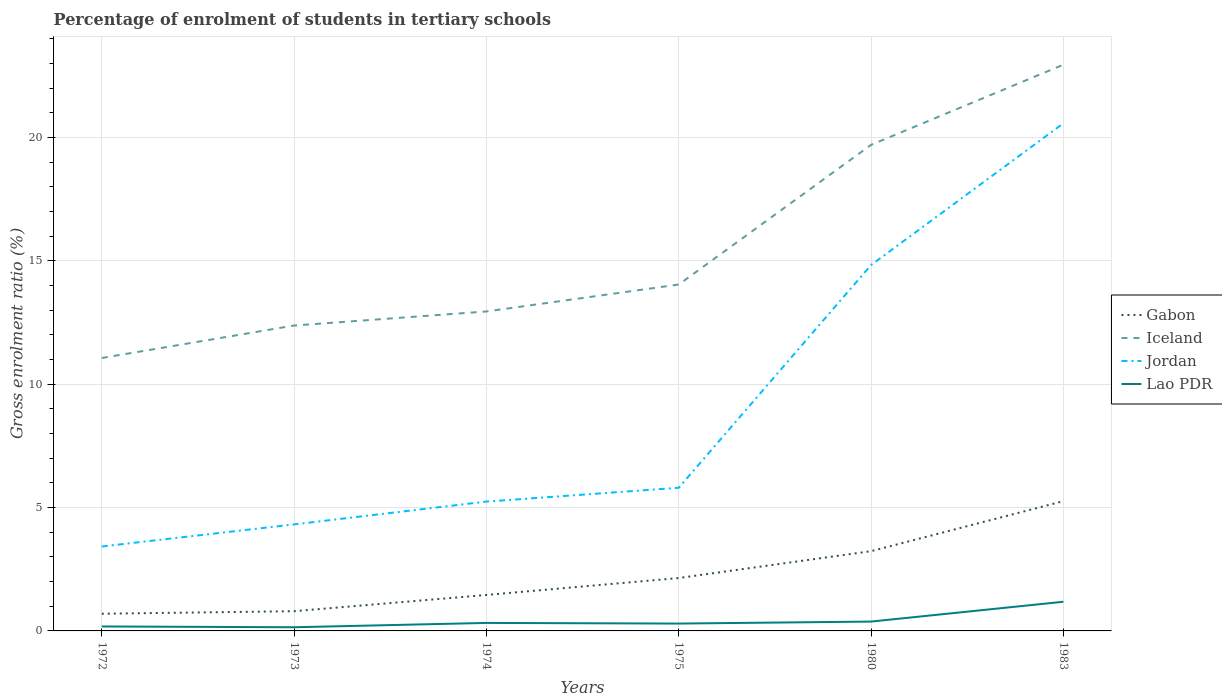Across all years, what is the maximum percentage of students enrolled in tertiary schools in Gabon?
Your response must be concise. 0.7. In which year was the percentage of students enrolled in tertiary schools in Gabon maximum?
Offer a terse response. 1972. What is the total percentage of students enrolled in tertiary schools in Gabon in the graph?
Provide a short and direct response. -3.8. What is the difference between the highest and the second highest percentage of students enrolled in tertiary schools in Jordan?
Provide a short and direct response. 17.16. What is the difference between the highest and the lowest percentage of students enrolled in tertiary schools in Iceland?
Keep it short and to the point. 2. How many lines are there?
Provide a succinct answer. 4. Are the values on the major ticks of Y-axis written in scientific E-notation?
Offer a very short reply. No. Does the graph contain any zero values?
Provide a succinct answer. No. Does the graph contain grids?
Your answer should be compact. Yes. How many legend labels are there?
Your response must be concise. 4. What is the title of the graph?
Give a very brief answer. Percentage of enrolment of students in tertiary schools. What is the label or title of the Y-axis?
Ensure brevity in your answer.  Gross enrolment ratio (%). What is the Gross enrolment ratio (%) of Gabon in 1972?
Keep it short and to the point. 0.7. What is the Gross enrolment ratio (%) of Iceland in 1972?
Your answer should be compact. 11.06. What is the Gross enrolment ratio (%) of Jordan in 1972?
Your answer should be compact. 3.42. What is the Gross enrolment ratio (%) in Lao PDR in 1972?
Offer a very short reply. 0.18. What is the Gross enrolment ratio (%) in Gabon in 1973?
Provide a short and direct response. 0.8. What is the Gross enrolment ratio (%) in Iceland in 1973?
Provide a short and direct response. 12.38. What is the Gross enrolment ratio (%) of Jordan in 1973?
Your answer should be compact. 4.32. What is the Gross enrolment ratio (%) of Lao PDR in 1973?
Your response must be concise. 0.15. What is the Gross enrolment ratio (%) in Gabon in 1974?
Provide a short and direct response. 1.46. What is the Gross enrolment ratio (%) in Iceland in 1974?
Ensure brevity in your answer.  12.95. What is the Gross enrolment ratio (%) in Jordan in 1974?
Give a very brief answer. 5.24. What is the Gross enrolment ratio (%) in Lao PDR in 1974?
Provide a succinct answer. 0.32. What is the Gross enrolment ratio (%) of Gabon in 1975?
Your response must be concise. 2.14. What is the Gross enrolment ratio (%) in Iceland in 1975?
Give a very brief answer. 14.04. What is the Gross enrolment ratio (%) of Jordan in 1975?
Your answer should be compact. 5.8. What is the Gross enrolment ratio (%) of Lao PDR in 1975?
Give a very brief answer. 0.3. What is the Gross enrolment ratio (%) in Gabon in 1980?
Your answer should be compact. 3.23. What is the Gross enrolment ratio (%) of Iceland in 1980?
Keep it short and to the point. 19.71. What is the Gross enrolment ratio (%) of Jordan in 1980?
Offer a terse response. 14.83. What is the Gross enrolment ratio (%) in Lao PDR in 1980?
Provide a succinct answer. 0.38. What is the Gross enrolment ratio (%) in Gabon in 1983?
Offer a very short reply. 5.26. What is the Gross enrolment ratio (%) in Iceland in 1983?
Keep it short and to the point. 22.96. What is the Gross enrolment ratio (%) of Jordan in 1983?
Provide a succinct answer. 20.58. What is the Gross enrolment ratio (%) in Lao PDR in 1983?
Offer a very short reply. 1.18. Across all years, what is the maximum Gross enrolment ratio (%) of Gabon?
Your answer should be very brief. 5.26. Across all years, what is the maximum Gross enrolment ratio (%) of Iceland?
Make the answer very short. 22.96. Across all years, what is the maximum Gross enrolment ratio (%) of Jordan?
Keep it short and to the point. 20.58. Across all years, what is the maximum Gross enrolment ratio (%) in Lao PDR?
Provide a short and direct response. 1.18. Across all years, what is the minimum Gross enrolment ratio (%) in Gabon?
Your response must be concise. 0.7. Across all years, what is the minimum Gross enrolment ratio (%) of Iceland?
Your answer should be very brief. 11.06. Across all years, what is the minimum Gross enrolment ratio (%) in Jordan?
Keep it short and to the point. 3.42. Across all years, what is the minimum Gross enrolment ratio (%) of Lao PDR?
Offer a very short reply. 0.15. What is the total Gross enrolment ratio (%) in Gabon in the graph?
Provide a short and direct response. 13.59. What is the total Gross enrolment ratio (%) in Iceland in the graph?
Keep it short and to the point. 93.1. What is the total Gross enrolment ratio (%) of Jordan in the graph?
Keep it short and to the point. 54.2. What is the total Gross enrolment ratio (%) in Lao PDR in the graph?
Your answer should be very brief. 2.51. What is the difference between the Gross enrolment ratio (%) in Gabon in 1972 and that in 1973?
Your answer should be compact. -0.1. What is the difference between the Gross enrolment ratio (%) in Iceland in 1972 and that in 1973?
Provide a short and direct response. -1.32. What is the difference between the Gross enrolment ratio (%) in Jordan in 1972 and that in 1973?
Provide a short and direct response. -0.9. What is the difference between the Gross enrolment ratio (%) in Lao PDR in 1972 and that in 1973?
Make the answer very short. 0.03. What is the difference between the Gross enrolment ratio (%) in Gabon in 1972 and that in 1974?
Give a very brief answer. -0.76. What is the difference between the Gross enrolment ratio (%) in Iceland in 1972 and that in 1974?
Offer a very short reply. -1.89. What is the difference between the Gross enrolment ratio (%) of Jordan in 1972 and that in 1974?
Keep it short and to the point. -1.82. What is the difference between the Gross enrolment ratio (%) of Lao PDR in 1972 and that in 1974?
Your response must be concise. -0.14. What is the difference between the Gross enrolment ratio (%) of Gabon in 1972 and that in 1975?
Give a very brief answer. -1.45. What is the difference between the Gross enrolment ratio (%) of Iceland in 1972 and that in 1975?
Provide a short and direct response. -2.98. What is the difference between the Gross enrolment ratio (%) in Jordan in 1972 and that in 1975?
Your answer should be compact. -2.38. What is the difference between the Gross enrolment ratio (%) in Lao PDR in 1972 and that in 1975?
Make the answer very short. -0.12. What is the difference between the Gross enrolment ratio (%) in Gabon in 1972 and that in 1980?
Keep it short and to the point. -2.54. What is the difference between the Gross enrolment ratio (%) of Iceland in 1972 and that in 1980?
Keep it short and to the point. -8.64. What is the difference between the Gross enrolment ratio (%) in Jordan in 1972 and that in 1980?
Ensure brevity in your answer.  -11.41. What is the difference between the Gross enrolment ratio (%) in Lao PDR in 1972 and that in 1980?
Keep it short and to the point. -0.2. What is the difference between the Gross enrolment ratio (%) in Gabon in 1972 and that in 1983?
Your answer should be very brief. -4.56. What is the difference between the Gross enrolment ratio (%) of Iceland in 1972 and that in 1983?
Ensure brevity in your answer.  -11.89. What is the difference between the Gross enrolment ratio (%) in Jordan in 1972 and that in 1983?
Ensure brevity in your answer.  -17.16. What is the difference between the Gross enrolment ratio (%) in Lao PDR in 1972 and that in 1983?
Keep it short and to the point. -1. What is the difference between the Gross enrolment ratio (%) of Gabon in 1973 and that in 1974?
Make the answer very short. -0.66. What is the difference between the Gross enrolment ratio (%) of Iceland in 1973 and that in 1974?
Ensure brevity in your answer.  -0.57. What is the difference between the Gross enrolment ratio (%) in Jordan in 1973 and that in 1974?
Your answer should be very brief. -0.93. What is the difference between the Gross enrolment ratio (%) in Lao PDR in 1973 and that in 1974?
Your answer should be compact. -0.18. What is the difference between the Gross enrolment ratio (%) of Gabon in 1973 and that in 1975?
Make the answer very short. -1.34. What is the difference between the Gross enrolment ratio (%) in Iceland in 1973 and that in 1975?
Give a very brief answer. -1.66. What is the difference between the Gross enrolment ratio (%) of Jordan in 1973 and that in 1975?
Provide a succinct answer. -1.49. What is the difference between the Gross enrolment ratio (%) in Lao PDR in 1973 and that in 1975?
Your response must be concise. -0.15. What is the difference between the Gross enrolment ratio (%) of Gabon in 1973 and that in 1980?
Offer a terse response. -2.43. What is the difference between the Gross enrolment ratio (%) of Iceland in 1973 and that in 1980?
Provide a succinct answer. -7.32. What is the difference between the Gross enrolment ratio (%) in Jordan in 1973 and that in 1980?
Your response must be concise. -10.51. What is the difference between the Gross enrolment ratio (%) of Lao PDR in 1973 and that in 1980?
Keep it short and to the point. -0.23. What is the difference between the Gross enrolment ratio (%) in Gabon in 1973 and that in 1983?
Your answer should be very brief. -4.46. What is the difference between the Gross enrolment ratio (%) in Iceland in 1973 and that in 1983?
Offer a terse response. -10.57. What is the difference between the Gross enrolment ratio (%) in Jordan in 1973 and that in 1983?
Your response must be concise. -16.26. What is the difference between the Gross enrolment ratio (%) of Lao PDR in 1973 and that in 1983?
Provide a short and direct response. -1.03. What is the difference between the Gross enrolment ratio (%) of Gabon in 1974 and that in 1975?
Give a very brief answer. -0.69. What is the difference between the Gross enrolment ratio (%) of Iceland in 1974 and that in 1975?
Offer a terse response. -1.09. What is the difference between the Gross enrolment ratio (%) in Jordan in 1974 and that in 1975?
Provide a succinct answer. -0.56. What is the difference between the Gross enrolment ratio (%) of Lao PDR in 1974 and that in 1975?
Make the answer very short. 0.03. What is the difference between the Gross enrolment ratio (%) of Gabon in 1974 and that in 1980?
Offer a terse response. -1.78. What is the difference between the Gross enrolment ratio (%) in Iceland in 1974 and that in 1980?
Your answer should be compact. -6.75. What is the difference between the Gross enrolment ratio (%) of Jordan in 1974 and that in 1980?
Give a very brief answer. -9.59. What is the difference between the Gross enrolment ratio (%) in Lao PDR in 1974 and that in 1980?
Make the answer very short. -0.06. What is the difference between the Gross enrolment ratio (%) in Gabon in 1974 and that in 1983?
Provide a succinct answer. -3.8. What is the difference between the Gross enrolment ratio (%) of Iceland in 1974 and that in 1983?
Give a very brief answer. -10. What is the difference between the Gross enrolment ratio (%) of Jordan in 1974 and that in 1983?
Provide a succinct answer. -15.34. What is the difference between the Gross enrolment ratio (%) of Lao PDR in 1974 and that in 1983?
Your answer should be compact. -0.86. What is the difference between the Gross enrolment ratio (%) of Gabon in 1975 and that in 1980?
Provide a short and direct response. -1.09. What is the difference between the Gross enrolment ratio (%) of Iceland in 1975 and that in 1980?
Your response must be concise. -5.66. What is the difference between the Gross enrolment ratio (%) of Jordan in 1975 and that in 1980?
Keep it short and to the point. -9.03. What is the difference between the Gross enrolment ratio (%) of Lao PDR in 1975 and that in 1980?
Provide a succinct answer. -0.08. What is the difference between the Gross enrolment ratio (%) in Gabon in 1975 and that in 1983?
Your answer should be very brief. -3.12. What is the difference between the Gross enrolment ratio (%) in Iceland in 1975 and that in 1983?
Keep it short and to the point. -8.91. What is the difference between the Gross enrolment ratio (%) of Jordan in 1975 and that in 1983?
Keep it short and to the point. -14.78. What is the difference between the Gross enrolment ratio (%) in Lao PDR in 1975 and that in 1983?
Make the answer very short. -0.88. What is the difference between the Gross enrolment ratio (%) in Gabon in 1980 and that in 1983?
Your answer should be very brief. -2.03. What is the difference between the Gross enrolment ratio (%) in Iceland in 1980 and that in 1983?
Ensure brevity in your answer.  -3.25. What is the difference between the Gross enrolment ratio (%) of Jordan in 1980 and that in 1983?
Ensure brevity in your answer.  -5.75. What is the difference between the Gross enrolment ratio (%) in Lao PDR in 1980 and that in 1983?
Keep it short and to the point. -0.8. What is the difference between the Gross enrolment ratio (%) of Gabon in 1972 and the Gross enrolment ratio (%) of Iceland in 1973?
Give a very brief answer. -11.68. What is the difference between the Gross enrolment ratio (%) in Gabon in 1972 and the Gross enrolment ratio (%) in Jordan in 1973?
Your response must be concise. -3.62. What is the difference between the Gross enrolment ratio (%) in Gabon in 1972 and the Gross enrolment ratio (%) in Lao PDR in 1973?
Your response must be concise. 0.55. What is the difference between the Gross enrolment ratio (%) in Iceland in 1972 and the Gross enrolment ratio (%) in Jordan in 1973?
Keep it short and to the point. 6.75. What is the difference between the Gross enrolment ratio (%) of Iceland in 1972 and the Gross enrolment ratio (%) of Lao PDR in 1973?
Offer a very short reply. 10.92. What is the difference between the Gross enrolment ratio (%) in Jordan in 1972 and the Gross enrolment ratio (%) in Lao PDR in 1973?
Give a very brief answer. 3.27. What is the difference between the Gross enrolment ratio (%) in Gabon in 1972 and the Gross enrolment ratio (%) in Iceland in 1974?
Ensure brevity in your answer.  -12.26. What is the difference between the Gross enrolment ratio (%) of Gabon in 1972 and the Gross enrolment ratio (%) of Jordan in 1974?
Provide a short and direct response. -4.55. What is the difference between the Gross enrolment ratio (%) in Gabon in 1972 and the Gross enrolment ratio (%) in Lao PDR in 1974?
Provide a succinct answer. 0.37. What is the difference between the Gross enrolment ratio (%) of Iceland in 1972 and the Gross enrolment ratio (%) of Jordan in 1974?
Your answer should be compact. 5.82. What is the difference between the Gross enrolment ratio (%) in Iceland in 1972 and the Gross enrolment ratio (%) in Lao PDR in 1974?
Provide a short and direct response. 10.74. What is the difference between the Gross enrolment ratio (%) in Jordan in 1972 and the Gross enrolment ratio (%) in Lao PDR in 1974?
Your answer should be very brief. 3.1. What is the difference between the Gross enrolment ratio (%) in Gabon in 1972 and the Gross enrolment ratio (%) in Iceland in 1975?
Keep it short and to the point. -13.35. What is the difference between the Gross enrolment ratio (%) of Gabon in 1972 and the Gross enrolment ratio (%) of Jordan in 1975?
Offer a terse response. -5.11. What is the difference between the Gross enrolment ratio (%) in Gabon in 1972 and the Gross enrolment ratio (%) in Lao PDR in 1975?
Keep it short and to the point. 0.4. What is the difference between the Gross enrolment ratio (%) of Iceland in 1972 and the Gross enrolment ratio (%) of Jordan in 1975?
Your answer should be compact. 5.26. What is the difference between the Gross enrolment ratio (%) of Iceland in 1972 and the Gross enrolment ratio (%) of Lao PDR in 1975?
Your answer should be very brief. 10.77. What is the difference between the Gross enrolment ratio (%) in Jordan in 1972 and the Gross enrolment ratio (%) in Lao PDR in 1975?
Your answer should be compact. 3.12. What is the difference between the Gross enrolment ratio (%) in Gabon in 1972 and the Gross enrolment ratio (%) in Iceland in 1980?
Offer a terse response. -19.01. What is the difference between the Gross enrolment ratio (%) in Gabon in 1972 and the Gross enrolment ratio (%) in Jordan in 1980?
Your answer should be very brief. -14.14. What is the difference between the Gross enrolment ratio (%) in Gabon in 1972 and the Gross enrolment ratio (%) in Lao PDR in 1980?
Offer a very short reply. 0.32. What is the difference between the Gross enrolment ratio (%) in Iceland in 1972 and the Gross enrolment ratio (%) in Jordan in 1980?
Your response must be concise. -3.77. What is the difference between the Gross enrolment ratio (%) in Iceland in 1972 and the Gross enrolment ratio (%) in Lao PDR in 1980?
Offer a very short reply. 10.69. What is the difference between the Gross enrolment ratio (%) of Jordan in 1972 and the Gross enrolment ratio (%) of Lao PDR in 1980?
Give a very brief answer. 3.04. What is the difference between the Gross enrolment ratio (%) in Gabon in 1972 and the Gross enrolment ratio (%) in Iceland in 1983?
Give a very brief answer. -22.26. What is the difference between the Gross enrolment ratio (%) in Gabon in 1972 and the Gross enrolment ratio (%) in Jordan in 1983?
Make the answer very short. -19.88. What is the difference between the Gross enrolment ratio (%) in Gabon in 1972 and the Gross enrolment ratio (%) in Lao PDR in 1983?
Ensure brevity in your answer.  -0.49. What is the difference between the Gross enrolment ratio (%) of Iceland in 1972 and the Gross enrolment ratio (%) of Jordan in 1983?
Ensure brevity in your answer.  -9.52. What is the difference between the Gross enrolment ratio (%) in Iceland in 1972 and the Gross enrolment ratio (%) in Lao PDR in 1983?
Offer a terse response. 9.88. What is the difference between the Gross enrolment ratio (%) in Jordan in 1972 and the Gross enrolment ratio (%) in Lao PDR in 1983?
Provide a short and direct response. 2.24. What is the difference between the Gross enrolment ratio (%) in Gabon in 1973 and the Gross enrolment ratio (%) in Iceland in 1974?
Keep it short and to the point. -12.15. What is the difference between the Gross enrolment ratio (%) of Gabon in 1973 and the Gross enrolment ratio (%) of Jordan in 1974?
Keep it short and to the point. -4.44. What is the difference between the Gross enrolment ratio (%) of Gabon in 1973 and the Gross enrolment ratio (%) of Lao PDR in 1974?
Give a very brief answer. 0.48. What is the difference between the Gross enrolment ratio (%) in Iceland in 1973 and the Gross enrolment ratio (%) in Jordan in 1974?
Offer a very short reply. 7.14. What is the difference between the Gross enrolment ratio (%) in Iceland in 1973 and the Gross enrolment ratio (%) in Lao PDR in 1974?
Your response must be concise. 12.06. What is the difference between the Gross enrolment ratio (%) in Jordan in 1973 and the Gross enrolment ratio (%) in Lao PDR in 1974?
Give a very brief answer. 3.99. What is the difference between the Gross enrolment ratio (%) of Gabon in 1973 and the Gross enrolment ratio (%) of Iceland in 1975?
Offer a terse response. -13.24. What is the difference between the Gross enrolment ratio (%) in Gabon in 1973 and the Gross enrolment ratio (%) in Jordan in 1975?
Your response must be concise. -5. What is the difference between the Gross enrolment ratio (%) in Gabon in 1973 and the Gross enrolment ratio (%) in Lao PDR in 1975?
Provide a short and direct response. 0.5. What is the difference between the Gross enrolment ratio (%) of Iceland in 1973 and the Gross enrolment ratio (%) of Jordan in 1975?
Provide a short and direct response. 6.58. What is the difference between the Gross enrolment ratio (%) in Iceland in 1973 and the Gross enrolment ratio (%) in Lao PDR in 1975?
Your answer should be very brief. 12.08. What is the difference between the Gross enrolment ratio (%) in Jordan in 1973 and the Gross enrolment ratio (%) in Lao PDR in 1975?
Your answer should be compact. 4.02. What is the difference between the Gross enrolment ratio (%) of Gabon in 1973 and the Gross enrolment ratio (%) of Iceland in 1980?
Keep it short and to the point. -18.91. What is the difference between the Gross enrolment ratio (%) in Gabon in 1973 and the Gross enrolment ratio (%) in Jordan in 1980?
Offer a very short reply. -14.03. What is the difference between the Gross enrolment ratio (%) of Gabon in 1973 and the Gross enrolment ratio (%) of Lao PDR in 1980?
Your response must be concise. 0.42. What is the difference between the Gross enrolment ratio (%) in Iceland in 1973 and the Gross enrolment ratio (%) in Jordan in 1980?
Provide a succinct answer. -2.45. What is the difference between the Gross enrolment ratio (%) of Iceland in 1973 and the Gross enrolment ratio (%) of Lao PDR in 1980?
Your answer should be compact. 12. What is the difference between the Gross enrolment ratio (%) of Jordan in 1973 and the Gross enrolment ratio (%) of Lao PDR in 1980?
Provide a short and direct response. 3.94. What is the difference between the Gross enrolment ratio (%) of Gabon in 1973 and the Gross enrolment ratio (%) of Iceland in 1983?
Keep it short and to the point. -22.16. What is the difference between the Gross enrolment ratio (%) of Gabon in 1973 and the Gross enrolment ratio (%) of Jordan in 1983?
Your answer should be very brief. -19.78. What is the difference between the Gross enrolment ratio (%) of Gabon in 1973 and the Gross enrolment ratio (%) of Lao PDR in 1983?
Your response must be concise. -0.38. What is the difference between the Gross enrolment ratio (%) of Iceland in 1973 and the Gross enrolment ratio (%) of Jordan in 1983?
Keep it short and to the point. -8.2. What is the difference between the Gross enrolment ratio (%) in Iceland in 1973 and the Gross enrolment ratio (%) in Lao PDR in 1983?
Your answer should be compact. 11.2. What is the difference between the Gross enrolment ratio (%) of Jordan in 1973 and the Gross enrolment ratio (%) of Lao PDR in 1983?
Provide a short and direct response. 3.14. What is the difference between the Gross enrolment ratio (%) in Gabon in 1974 and the Gross enrolment ratio (%) in Iceland in 1975?
Your answer should be very brief. -12.59. What is the difference between the Gross enrolment ratio (%) in Gabon in 1974 and the Gross enrolment ratio (%) in Jordan in 1975?
Ensure brevity in your answer.  -4.35. What is the difference between the Gross enrolment ratio (%) in Gabon in 1974 and the Gross enrolment ratio (%) in Lao PDR in 1975?
Give a very brief answer. 1.16. What is the difference between the Gross enrolment ratio (%) of Iceland in 1974 and the Gross enrolment ratio (%) of Jordan in 1975?
Your answer should be very brief. 7.15. What is the difference between the Gross enrolment ratio (%) of Iceland in 1974 and the Gross enrolment ratio (%) of Lao PDR in 1975?
Offer a terse response. 12.65. What is the difference between the Gross enrolment ratio (%) of Jordan in 1974 and the Gross enrolment ratio (%) of Lao PDR in 1975?
Your answer should be very brief. 4.95. What is the difference between the Gross enrolment ratio (%) of Gabon in 1974 and the Gross enrolment ratio (%) of Iceland in 1980?
Provide a succinct answer. -18.25. What is the difference between the Gross enrolment ratio (%) of Gabon in 1974 and the Gross enrolment ratio (%) of Jordan in 1980?
Make the answer very short. -13.38. What is the difference between the Gross enrolment ratio (%) in Gabon in 1974 and the Gross enrolment ratio (%) in Lao PDR in 1980?
Offer a very short reply. 1.08. What is the difference between the Gross enrolment ratio (%) of Iceland in 1974 and the Gross enrolment ratio (%) of Jordan in 1980?
Offer a very short reply. -1.88. What is the difference between the Gross enrolment ratio (%) in Iceland in 1974 and the Gross enrolment ratio (%) in Lao PDR in 1980?
Provide a succinct answer. 12.57. What is the difference between the Gross enrolment ratio (%) of Jordan in 1974 and the Gross enrolment ratio (%) of Lao PDR in 1980?
Provide a succinct answer. 4.87. What is the difference between the Gross enrolment ratio (%) in Gabon in 1974 and the Gross enrolment ratio (%) in Iceland in 1983?
Ensure brevity in your answer.  -21.5. What is the difference between the Gross enrolment ratio (%) of Gabon in 1974 and the Gross enrolment ratio (%) of Jordan in 1983?
Ensure brevity in your answer.  -19.12. What is the difference between the Gross enrolment ratio (%) in Gabon in 1974 and the Gross enrolment ratio (%) in Lao PDR in 1983?
Provide a succinct answer. 0.28. What is the difference between the Gross enrolment ratio (%) in Iceland in 1974 and the Gross enrolment ratio (%) in Jordan in 1983?
Provide a short and direct response. -7.63. What is the difference between the Gross enrolment ratio (%) of Iceland in 1974 and the Gross enrolment ratio (%) of Lao PDR in 1983?
Make the answer very short. 11.77. What is the difference between the Gross enrolment ratio (%) in Jordan in 1974 and the Gross enrolment ratio (%) in Lao PDR in 1983?
Your answer should be very brief. 4.06. What is the difference between the Gross enrolment ratio (%) in Gabon in 1975 and the Gross enrolment ratio (%) in Iceland in 1980?
Ensure brevity in your answer.  -17.56. What is the difference between the Gross enrolment ratio (%) of Gabon in 1975 and the Gross enrolment ratio (%) of Jordan in 1980?
Your answer should be compact. -12.69. What is the difference between the Gross enrolment ratio (%) in Gabon in 1975 and the Gross enrolment ratio (%) in Lao PDR in 1980?
Offer a terse response. 1.77. What is the difference between the Gross enrolment ratio (%) of Iceland in 1975 and the Gross enrolment ratio (%) of Jordan in 1980?
Ensure brevity in your answer.  -0.79. What is the difference between the Gross enrolment ratio (%) in Iceland in 1975 and the Gross enrolment ratio (%) in Lao PDR in 1980?
Offer a terse response. 13.66. What is the difference between the Gross enrolment ratio (%) of Jordan in 1975 and the Gross enrolment ratio (%) of Lao PDR in 1980?
Make the answer very short. 5.43. What is the difference between the Gross enrolment ratio (%) in Gabon in 1975 and the Gross enrolment ratio (%) in Iceland in 1983?
Ensure brevity in your answer.  -20.81. What is the difference between the Gross enrolment ratio (%) in Gabon in 1975 and the Gross enrolment ratio (%) in Jordan in 1983?
Keep it short and to the point. -18.44. What is the difference between the Gross enrolment ratio (%) of Gabon in 1975 and the Gross enrolment ratio (%) of Lao PDR in 1983?
Your response must be concise. 0.96. What is the difference between the Gross enrolment ratio (%) of Iceland in 1975 and the Gross enrolment ratio (%) of Jordan in 1983?
Give a very brief answer. -6.54. What is the difference between the Gross enrolment ratio (%) in Iceland in 1975 and the Gross enrolment ratio (%) in Lao PDR in 1983?
Provide a succinct answer. 12.86. What is the difference between the Gross enrolment ratio (%) of Jordan in 1975 and the Gross enrolment ratio (%) of Lao PDR in 1983?
Ensure brevity in your answer.  4.62. What is the difference between the Gross enrolment ratio (%) in Gabon in 1980 and the Gross enrolment ratio (%) in Iceland in 1983?
Ensure brevity in your answer.  -19.72. What is the difference between the Gross enrolment ratio (%) in Gabon in 1980 and the Gross enrolment ratio (%) in Jordan in 1983?
Ensure brevity in your answer.  -17.35. What is the difference between the Gross enrolment ratio (%) of Gabon in 1980 and the Gross enrolment ratio (%) of Lao PDR in 1983?
Your response must be concise. 2.05. What is the difference between the Gross enrolment ratio (%) of Iceland in 1980 and the Gross enrolment ratio (%) of Jordan in 1983?
Keep it short and to the point. -0.88. What is the difference between the Gross enrolment ratio (%) in Iceland in 1980 and the Gross enrolment ratio (%) in Lao PDR in 1983?
Give a very brief answer. 18.52. What is the difference between the Gross enrolment ratio (%) of Jordan in 1980 and the Gross enrolment ratio (%) of Lao PDR in 1983?
Your response must be concise. 13.65. What is the average Gross enrolment ratio (%) of Gabon per year?
Your response must be concise. 2.27. What is the average Gross enrolment ratio (%) in Iceland per year?
Keep it short and to the point. 15.52. What is the average Gross enrolment ratio (%) in Jordan per year?
Provide a succinct answer. 9.03. What is the average Gross enrolment ratio (%) in Lao PDR per year?
Keep it short and to the point. 0.42. In the year 1972, what is the difference between the Gross enrolment ratio (%) of Gabon and Gross enrolment ratio (%) of Iceland?
Give a very brief answer. -10.37. In the year 1972, what is the difference between the Gross enrolment ratio (%) in Gabon and Gross enrolment ratio (%) in Jordan?
Your answer should be very brief. -2.73. In the year 1972, what is the difference between the Gross enrolment ratio (%) of Gabon and Gross enrolment ratio (%) of Lao PDR?
Keep it short and to the point. 0.52. In the year 1972, what is the difference between the Gross enrolment ratio (%) in Iceland and Gross enrolment ratio (%) in Jordan?
Provide a succinct answer. 7.64. In the year 1972, what is the difference between the Gross enrolment ratio (%) in Iceland and Gross enrolment ratio (%) in Lao PDR?
Provide a short and direct response. 10.88. In the year 1972, what is the difference between the Gross enrolment ratio (%) of Jordan and Gross enrolment ratio (%) of Lao PDR?
Keep it short and to the point. 3.24. In the year 1973, what is the difference between the Gross enrolment ratio (%) of Gabon and Gross enrolment ratio (%) of Iceland?
Make the answer very short. -11.58. In the year 1973, what is the difference between the Gross enrolment ratio (%) in Gabon and Gross enrolment ratio (%) in Jordan?
Offer a very short reply. -3.52. In the year 1973, what is the difference between the Gross enrolment ratio (%) of Gabon and Gross enrolment ratio (%) of Lao PDR?
Provide a succinct answer. 0.65. In the year 1973, what is the difference between the Gross enrolment ratio (%) in Iceland and Gross enrolment ratio (%) in Jordan?
Your response must be concise. 8.06. In the year 1973, what is the difference between the Gross enrolment ratio (%) in Iceland and Gross enrolment ratio (%) in Lao PDR?
Offer a very short reply. 12.23. In the year 1973, what is the difference between the Gross enrolment ratio (%) in Jordan and Gross enrolment ratio (%) in Lao PDR?
Make the answer very short. 4.17. In the year 1974, what is the difference between the Gross enrolment ratio (%) of Gabon and Gross enrolment ratio (%) of Iceland?
Your answer should be compact. -11.49. In the year 1974, what is the difference between the Gross enrolment ratio (%) of Gabon and Gross enrolment ratio (%) of Jordan?
Your answer should be compact. -3.79. In the year 1974, what is the difference between the Gross enrolment ratio (%) in Gabon and Gross enrolment ratio (%) in Lao PDR?
Offer a very short reply. 1.13. In the year 1974, what is the difference between the Gross enrolment ratio (%) of Iceland and Gross enrolment ratio (%) of Jordan?
Ensure brevity in your answer.  7.71. In the year 1974, what is the difference between the Gross enrolment ratio (%) in Iceland and Gross enrolment ratio (%) in Lao PDR?
Your response must be concise. 12.63. In the year 1974, what is the difference between the Gross enrolment ratio (%) of Jordan and Gross enrolment ratio (%) of Lao PDR?
Offer a terse response. 4.92. In the year 1975, what is the difference between the Gross enrolment ratio (%) in Gabon and Gross enrolment ratio (%) in Iceland?
Your response must be concise. -11.9. In the year 1975, what is the difference between the Gross enrolment ratio (%) of Gabon and Gross enrolment ratio (%) of Jordan?
Give a very brief answer. -3.66. In the year 1975, what is the difference between the Gross enrolment ratio (%) in Gabon and Gross enrolment ratio (%) in Lao PDR?
Give a very brief answer. 1.85. In the year 1975, what is the difference between the Gross enrolment ratio (%) of Iceland and Gross enrolment ratio (%) of Jordan?
Provide a succinct answer. 8.24. In the year 1975, what is the difference between the Gross enrolment ratio (%) in Iceland and Gross enrolment ratio (%) in Lao PDR?
Your answer should be very brief. 13.75. In the year 1975, what is the difference between the Gross enrolment ratio (%) of Jordan and Gross enrolment ratio (%) of Lao PDR?
Ensure brevity in your answer.  5.51. In the year 1980, what is the difference between the Gross enrolment ratio (%) in Gabon and Gross enrolment ratio (%) in Iceland?
Offer a very short reply. -16.47. In the year 1980, what is the difference between the Gross enrolment ratio (%) of Gabon and Gross enrolment ratio (%) of Jordan?
Make the answer very short. -11.6. In the year 1980, what is the difference between the Gross enrolment ratio (%) in Gabon and Gross enrolment ratio (%) in Lao PDR?
Offer a terse response. 2.85. In the year 1980, what is the difference between the Gross enrolment ratio (%) of Iceland and Gross enrolment ratio (%) of Jordan?
Ensure brevity in your answer.  4.87. In the year 1980, what is the difference between the Gross enrolment ratio (%) in Iceland and Gross enrolment ratio (%) in Lao PDR?
Your response must be concise. 19.33. In the year 1980, what is the difference between the Gross enrolment ratio (%) in Jordan and Gross enrolment ratio (%) in Lao PDR?
Provide a short and direct response. 14.45. In the year 1983, what is the difference between the Gross enrolment ratio (%) of Gabon and Gross enrolment ratio (%) of Iceland?
Make the answer very short. -17.69. In the year 1983, what is the difference between the Gross enrolment ratio (%) in Gabon and Gross enrolment ratio (%) in Jordan?
Provide a succinct answer. -15.32. In the year 1983, what is the difference between the Gross enrolment ratio (%) of Gabon and Gross enrolment ratio (%) of Lao PDR?
Your response must be concise. 4.08. In the year 1983, what is the difference between the Gross enrolment ratio (%) in Iceland and Gross enrolment ratio (%) in Jordan?
Give a very brief answer. 2.38. In the year 1983, what is the difference between the Gross enrolment ratio (%) of Iceland and Gross enrolment ratio (%) of Lao PDR?
Provide a short and direct response. 21.77. In the year 1983, what is the difference between the Gross enrolment ratio (%) in Jordan and Gross enrolment ratio (%) in Lao PDR?
Ensure brevity in your answer.  19.4. What is the ratio of the Gross enrolment ratio (%) of Gabon in 1972 to that in 1973?
Your response must be concise. 0.87. What is the ratio of the Gross enrolment ratio (%) of Iceland in 1972 to that in 1973?
Your answer should be very brief. 0.89. What is the ratio of the Gross enrolment ratio (%) in Jordan in 1972 to that in 1973?
Offer a terse response. 0.79. What is the ratio of the Gross enrolment ratio (%) in Lao PDR in 1972 to that in 1973?
Provide a succinct answer. 1.22. What is the ratio of the Gross enrolment ratio (%) of Gabon in 1972 to that in 1974?
Offer a very short reply. 0.48. What is the ratio of the Gross enrolment ratio (%) of Iceland in 1972 to that in 1974?
Your response must be concise. 0.85. What is the ratio of the Gross enrolment ratio (%) of Jordan in 1972 to that in 1974?
Ensure brevity in your answer.  0.65. What is the ratio of the Gross enrolment ratio (%) in Lao PDR in 1972 to that in 1974?
Keep it short and to the point. 0.56. What is the ratio of the Gross enrolment ratio (%) of Gabon in 1972 to that in 1975?
Offer a terse response. 0.32. What is the ratio of the Gross enrolment ratio (%) in Iceland in 1972 to that in 1975?
Your answer should be very brief. 0.79. What is the ratio of the Gross enrolment ratio (%) of Jordan in 1972 to that in 1975?
Your answer should be compact. 0.59. What is the ratio of the Gross enrolment ratio (%) in Lao PDR in 1972 to that in 1975?
Provide a short and direct response. 0.61. What is the ratio of the Gross enrolment ratio (%) in Gabon in 1972 to that in 1980?
Ensure brevity in your answer.  0.22. What is the ratio of the Gross enrolment ratio (%) in Iceland in 1972 to that in 1980?
Your answer should be very brief. 0.56. What is the ratio of the Gross enrolment ratio (%) of Jordan in 1972 to that in 1980?
Ensure brevity in your answer.  0.23. What is the ratio of the Gross enrolment ratio (%) of Lao PDR in 1972 to that in 1980?
Keep it short and to the point. 0.48. What is the ratio of the Gross enrolment ratio (%) in Gabon in 1972 to that in 1983?
Your answer should be very brief. 0.13. What is the ratio of the Gross enrolment ratio (%) of Iceland in 1972 to that in 1983?
Your answer should be compact. 0.48. What is the ratio of the Gross enrolment ratio (%) in Jordan in 1972 to that in 1983?
Make the answer very short. 0.17. What is the ratio of the Gross enrolment ratio (%) of Lao PDR in 1972 to that in 1983?
Offer a terse response. 0.15. What is the ratio of the Gross enrolment ratio (%) in Gabon in 1973 to that in 1974?
Your answer should be compact. 0.55. What is the ratio of the Gross enrolment ratio (%) of Iceland in 1973 to that in 1974?
Make the answer very short. 0.96. What is the ratio of the Gross enrolment ratio (%) of Jordan in 1973 to that in 1974?
Your answer should be compact. 0.82. What is the ratio of the Gross enrolment ratio (%) in Lao PDR in 1973 to that in 1974?
Your response must be concise. 0.46. What is the ratio of the Gross enrolment ratio (%) in Gabon in 1973 to that in 1975?
Ensure brevity in your answer.  0.37. What is the ratio of the Gross enrolment ratio (%) of Iceland in 1973 to that in 1975?
Your answer should be compact. 0.88. What is the ratio of the Gross enrolment ratio (%) in Jordan in 1973 to that in 1975?
Make the answer very short. 0.74. What is the ratio of the Gross enrolment ratio (%) in Lao PDR in 1973 to that in 1975?
Ensure brevity in your answer.  0.5. What is the ratio of the Gross enrolment ratio (%) in Gabon in 1973 to that in 1980?
Your answer should be compact. 0.25. What is the ratio of the Gross enrolment ratio (%) of Iceland in 1973 to that in 1980?
Provide a short and direct response. 0.63. What is the ratio of the Gross enrolment ratio (%) of Jordan in 1973 to that in 1980?
Offer a terse response. 0.29. What is the ratio of the Gross enrolment ratio (%) of Lao PDR in 1973 to that in 1980?
Keep it short and to the point. 0.39. What is the ratio of the Gross enrolment ratio (%) in Gabon in 1973 to that in 1983?
Your answer should be compact. 0.15. What is the ratio of the Gross enrolment ratio (%) in Iceland in 1973 to that in 1983?
Provide a succinct answer. 0.54. What is the ratio of the Gross enrolment ratio (%) in Jordan in 1973 to that in 1983?
Your response must be concise. 0.21. What is the ratio of the Gross enrolment ratio (%) in Lao PDR in 1973 to that in 1983?
Your answer should be very brief. 0.13. What is the ratio of the Gross enrolment ratio (%) of Gabon in 1974 to that in 1975?
Make the answer very short. 0.68. What is the ratio of the Gross enrolment ratio (%) in Iceland in 1974 to that in 1975?
Ensure brevity in your answer.  0.92. What is the ratio of the Gross enrolment ratio (%) of Jordan in 1974 to that in 1975?
Ensure brevity in your answer.  0.9. What is the ratio of the Gross enrolment ratio (%) of Lao PDR in 1974 to that in 1975?
Your answer should be very brief. 1.09. What is the ratio of the Gross enrolment ratio (%) of Gabon in 1974 to that in 1980?
Keep it short and to the point. 0.45. What is the ratio of the Gross enrolment ratio (%) in Iceland in 1974 to that in 1980?
Offer a very short reply. 0.66. What is the ratio of the Gross enrolment ratio (%) of Jordan in 1974 to that in 1980?
Your answer should be compact. 0.35. What is the ratio of the Gross enrolment ratio (%) of Lao PDR in 1974 to that in 1980?
Offer a terse response. 0.85. What is the ratio of the Gross enrolment ratio (%) of Gabon in 1974 to that in 1983?
Offer a terse response. 0.28. What is the ratio of the Gross enrolment ratio (%) of Iceland in 1974 to that in 1983?
Provide a short and direct response. 0.56. What is the ratio of the Gross enrolment ratio (%) of Jordan in 1974 to that in 1983?
Ensure brevity in your answer.  0.25. What is the ratio of the Gross enrolment ratio (%) of Lao PDR in 1974 to that in 1983?
Your answer should be very brief. 0.27. What is the ratio of the Gross enrolment ratio (%) in Gabon in 1975 to that in 1980?
Provide a short and direct response. 0.66. What is the ratio of the Gross enrolment ratio (%) in Iceland in 1975 to that in 1980?
Give a very brief answer. 0.71. What is the ratio of the Gross enrolment ratio (%) of Jordan in 1975 to that in 1980?
Offer a very short reply. 0.39. What is the ratio of the Gross enrolment ratio (%) in Lao PDR in 1975 to that in 1980?
Give a very brief answer. 0.79. What is the ratio of the Gross enrolment ratio (%) of Gabon in 1975 to that in 1983?
Provide a succinct answer. 0.41. What is the ratio of the Gross enrolment ratio (%) of Iceland in 1975 to that in 1983?
Keep it short and to the point. 0.61. What is the ratio of the Gross enrolment ratio (%) in Jordan in 1975 to that in 1983?
Offer a terse response. 0.28. What is the ratio of the Gross enrolment ratio (%) in Lao PDR in 1975 to that in 1983?
Provide a short and direct response. 0.25. What is the ratio of the Gross enrolment ratio (%) of Gabon in 1980 to that in 1983?
Your response must be concise. 0.61. What is the ratio of the Gross enrolment ratio (%) of Iceland in 1980 to that in 1983?
Keep it short and to the point. 0.86. What is the ratio of the Gross enrolment ratio (%) in Jordan in 1980 to that in 1983?
Offer a very short reply. 0.72. What is the ratio of the Gross enrolment ratio (%) of Lao PDR in 1980 to that in 1983?
Offer a terse response. 0.32. What is the difference between the highest and the second highest Gross enrolment ratio (%) in Gabon?
Your response must be concise. 2.03. What is the difference between the highest and the second highest Gross enrolment ratio (%) in Iceland?
Ensure brevity in your answer.  3.25. What is the difference between the highest and the second highest Gross enrolment ratio (%) of Jordan?
Make the answer very short. 5.75. What is the difference between the highest and the second highest Gross enrolment ratio (%) in Lao PDR?
Offer a terse response. 0.8. What is the difference between the highest and the lowest Gross enrolment ratio (%) in Gabon?
Make the answer very short. 4.56. What is the difference between the highest and the lowest Gross enrolment ratio (%) of Iceland?
Make the answer very short. 11.89. What is the difference between the highest and the lowest Gross enrolment ratio (%) in Jordan?
Ensure brevity in your answer.  17.16. What is the difference between the highest and the lowest Gross enrolment ratio (%) in Lao PDR?
Provide a succinct answer. 1.03. 